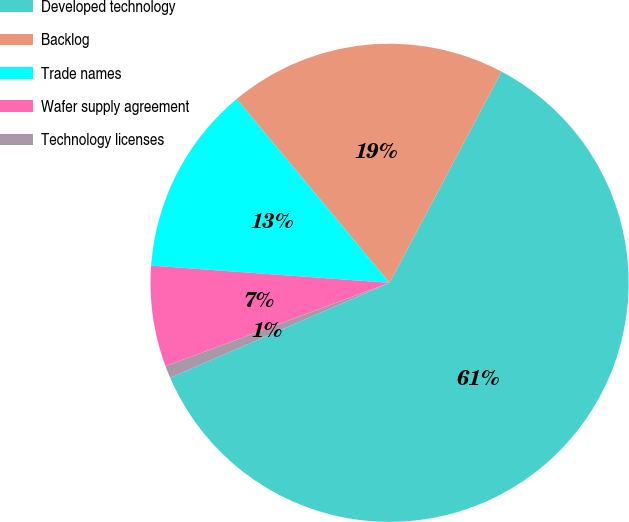<chart> <loc_0><loc_0><loc_500><loc_500><pie_chart><fcel>Developed technology<fcel>Backlog<fcel>Trade names<fcel>Wafer supply agreement<fcel>Technology licenses<nl><fcel>60.74%<fcel>18.8%<fcel>12.81%<fcel>6.82%<fcel>0.83%<nl></chart> 